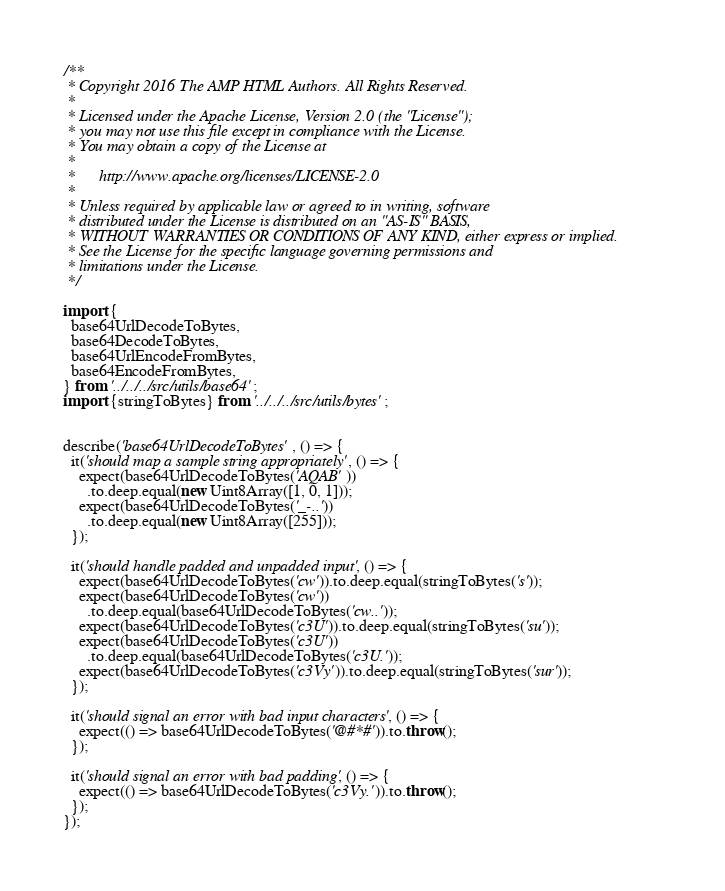Convert code to text. <code><loc_0><loc_0><loc_500><loc_500><_JavaScript_>/**
 * Copyright 2016 The AMP HTML Authors. All Rights Reserved.
 *
 * Licensed under the Apache License, Version 2.0 (the "License");
 * you may not use this file except in compliance with the License.
 * You may obtain a copy of the License at
 *
 *      http://www.apache.org/licenses/LICENSE-2.0
 *
 * Unless required by applicable law or agreed to in writing, software
 * distributed under the License is distributed on an "AS-IS" BASIS,
 * WITHOUT WARRANTIES OR CONDITIONS OF ANY KIND, either express or implied.
 * See the License for the specific language governing permissions and
 * limitations under the License.
 */

import {
  base64UrlDecodeToBytes,
  base64DecodeToBytes,
  base64UrlEncodeFromBytes,
  base64EncodeFromBytes,
} from '../../../src/utils/base64';
import {stringToBytes} from '../../../src/utils/bytes';


describe('base64UrlDecodeToBytes', () => {
  it('should map a sample string appropriately', () => {
    expect(base64UrlDecodeToBytes('AQAB'))
      .to.deep.equal(new Uint8Array([1, 0, 1]));
    expect(base64UrlDecodeToBytes('_-..'))
      .to.deep.equal(new Uint8Array([255]));
  });

  it('should handle padded and unpadded input', () => {
    expect(base64UrlDecodeToBytes('cw')).to.deep.equal(stringToBytes('s'));
    expect(base64UrlDecodeToBytes('cw'))
      .to.deep.equal(base64UrlDecodeToBytes('cw..'));
    expect(base64UrlDecodeToBytes('c3U')).to.deep.equal(stringToBytes('su'));
    expect(base64UrlDecodeToBytes('c3U'))
      .to.deep.equal(base64UrlDecodeToBytes('c3U.'));
    expect(base64UrlDecodeToBytes('c3Vy')).to.deep.equal(stringToBytes('sur'));
  });

  it('should signal an error with bad input characters', () => {
    expect(() => base64UrlDecodeToBytes('@#*#')).to.throw();
  });

  it('should signal an error with bad padding', () => {
    expect(() => base64UrlDecodeToBytes('c3Vy.')).to.throw();
  });
});
</code> 